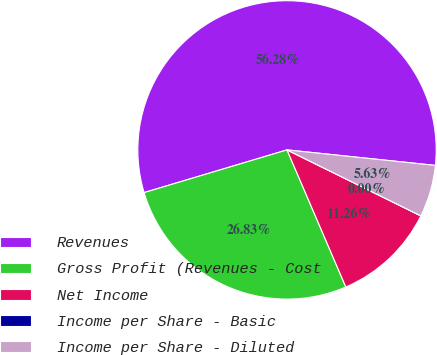Convert chart. <chart><loc_0><loc_0><loc_500><loc_500><pie_chart><fcel>Revenues<fcel>Gross Profit (Revenues - Cost<fcel>Net Income<fcel>Income per Share - Basic<fcel>Income per Share - Diluted<nl><fcel>56.28%<fcel>26.83%<fcel>11.26%<fcel>0.0%<fcel>5.63%<nl></chart> 